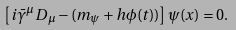<formula> <loc_0><loc_0><loc_500><loc_500>\left [ i \bar { \gamma } ^ { \mu } D _ { \mu } - ( m _ { \psi } + h \phi ( t ) ) \right ] \psi ( x ) = 0 .</formula> 